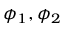<formula> <loc_0><loc_0><loc_500><loc_500>\phi _ { 1 } , \phi _ { 2 }</formula> 